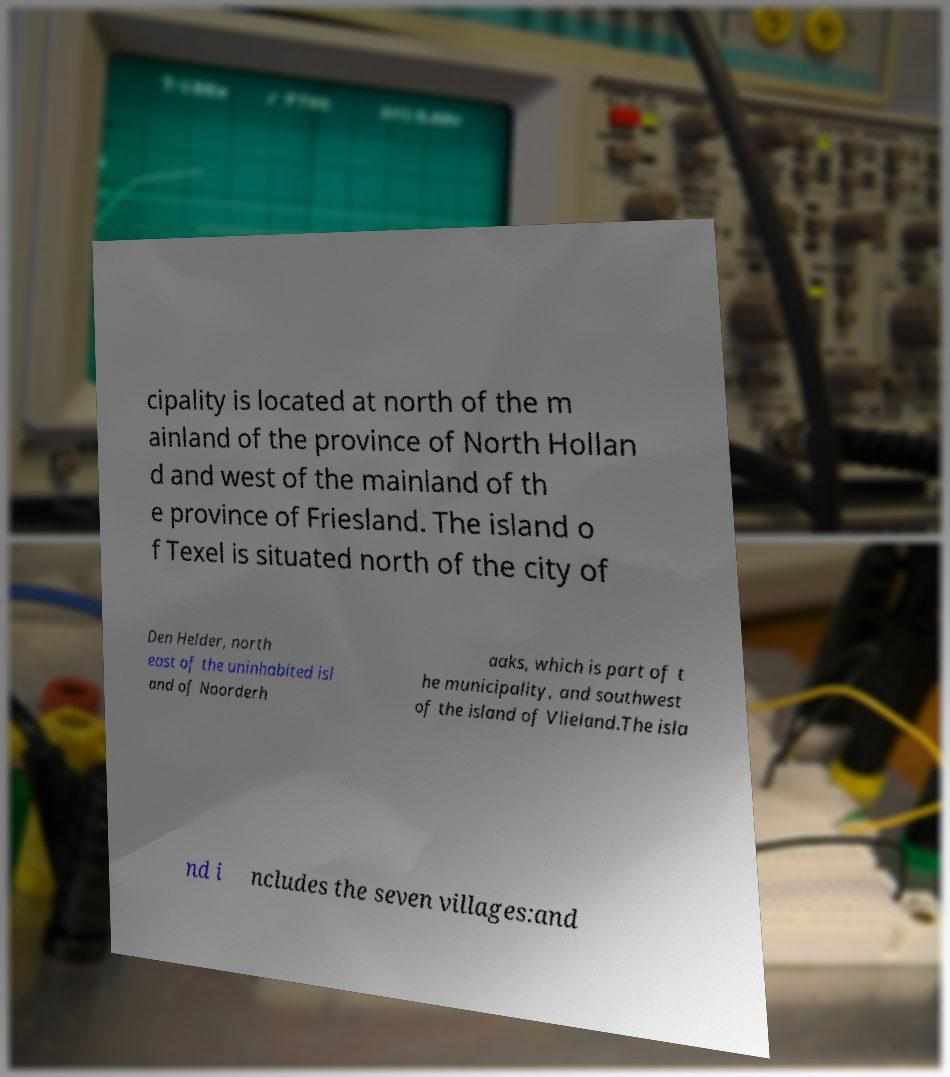Can you accurately transcribe the text from the provided image for me? cipality is located at north of the m ainland of the province of North Hollan d and west of the mainland of th e province of Friesland. The island o f Texel is situated north of the city of Den Helder, north east of the uninhabited isl and of Noorderh aaks, which is part of t he municipality, and southwest of the island of Vlieland.The isla nd i ncludes the seven villages:and 